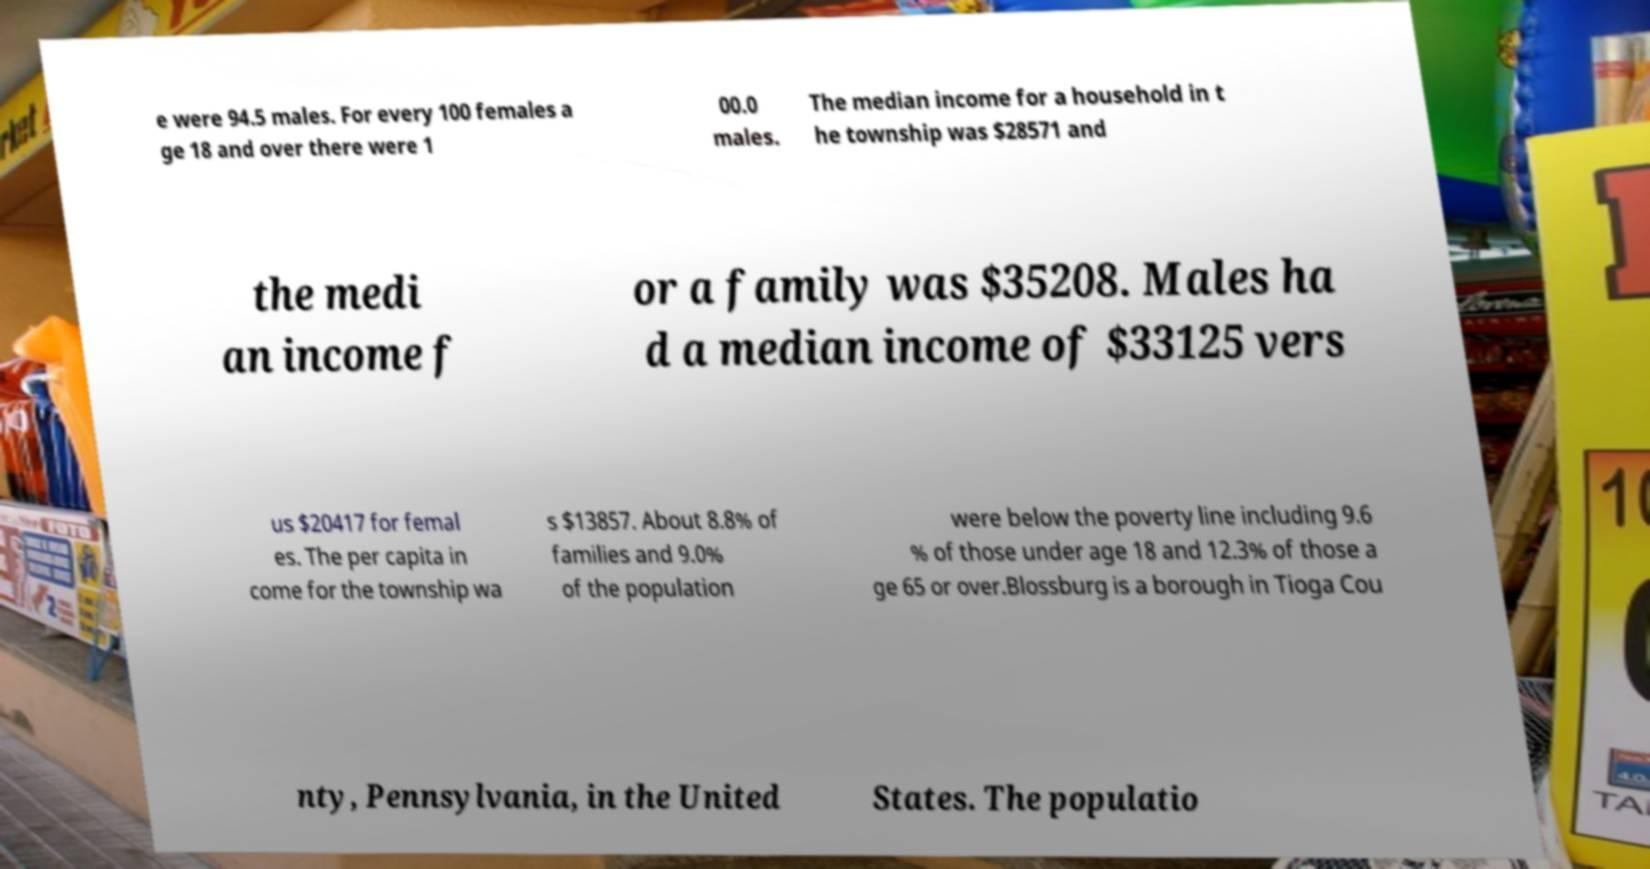For documentation purposes, I need the text within this image transcribed. Could you provide that? e were 94.5 males. For every 100 females a ge 18 and over there were 1 00.0 males. The median income for a household in t he township was $28571 and the medi an income f or a family was $35208. Males ha d a median income of $33125 vers us $20417 for femal es. The per capita in come for the township wa s $13857. About 8.8% of families and 9.0% of the population were below the poverty line including 9.6 % of those under age 18 and 12.3% of those a ge 65 or over.Blossburg is a borough in Tioga Cou nty, Pennsylvania, in the United States. The populatio 